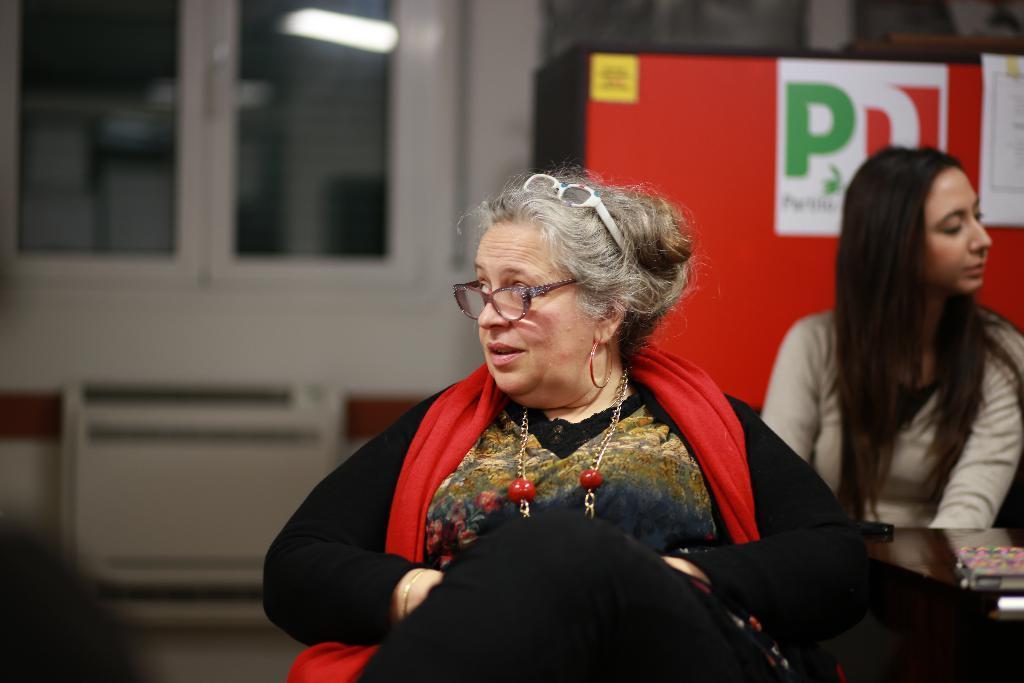In one or two sentences, can you explain what this image depicts? In this picture there is an old woman who is wearing spectacle and black dress. Beside her we can see a woman who is wearing brown t-shirt and she is sitting on the chair. On the table we can see book. In the background there is a board near to the window. On the top there is a light. 